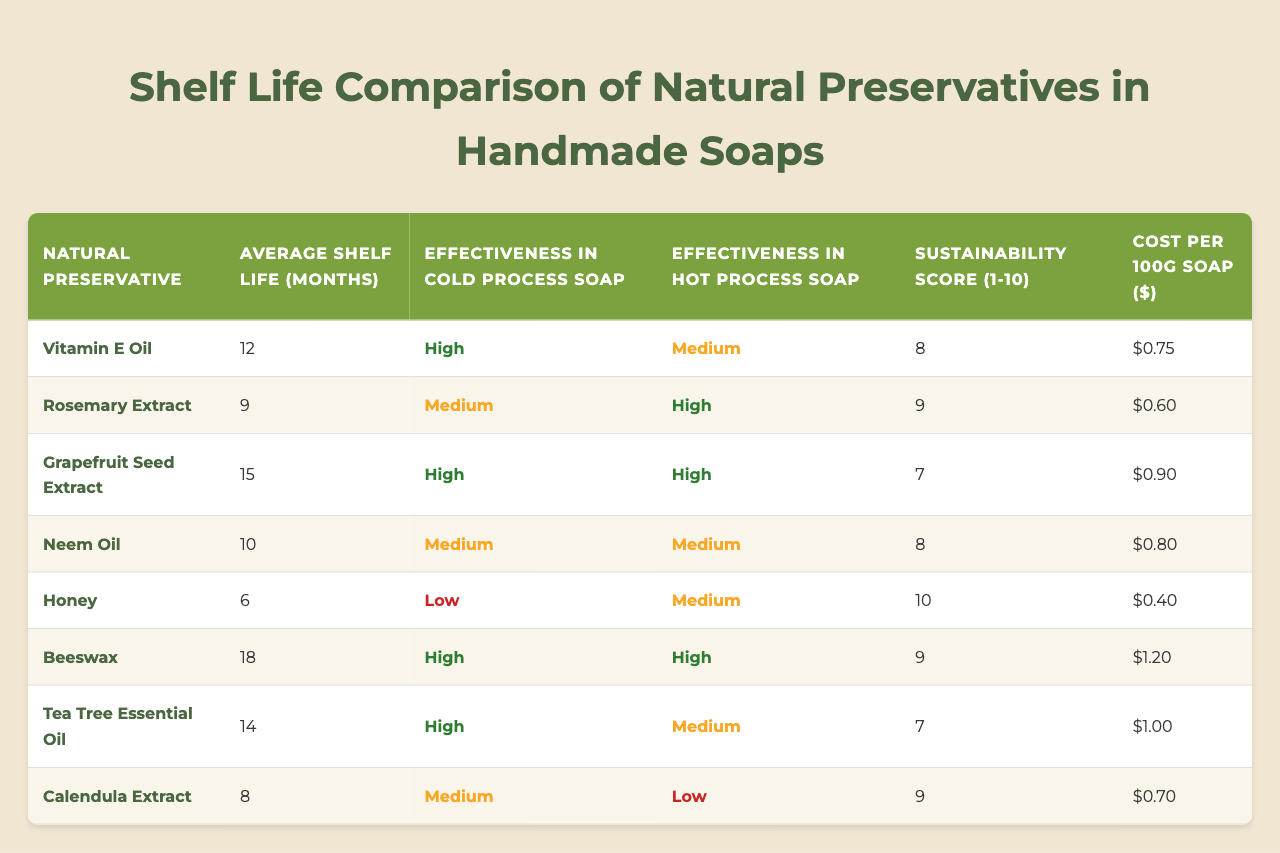What is the average shelf life of the natural preservatives listed? To find the average shelf life, we can sum the shelf lives of all preservatives: (12 + 9 + 15 + 10 + 6 + 18 + 14 + 8) = 92 months. There are 8 preservatives, so the average shelf life is 92/8 = 11.5 months.
Answer: 11.5 months Which natural preservative has the highest sustainability score? Looking at the sustainability scores in the table, the highest score is 10, which is associated with Honey.
Answer: Honey Is Grapefruit Seed Extract more effective in cold process soap than Neem Oil? Grapefruit Seed Extract has "High" effectiveness in cold process soap, while Neem Oil has "Medium." Therefore, Grapefruit Seed Extract is indeed more effective.
Answer: Yes What is the cost per 100g of Beeswax? The cost per 100g of Beeswax is listed directly in the table as $1.20.
Answer: $1.20 Which natural preservative has the longest average shelf life, and what is that shelf life? Looking at the average shelf life values, Grapefruit Seed Extract has the longest shelf life at 15 months.
Answer: Grapefruit Seed Extract, 15 months Are all the natural preservatives effective in hot process soap? The effectiveness in hot process soap for some preservatives is "Low," such as Calendula Extract. This indicates that not all preservatives are effective.
Answer: No If you only consider the preservatives with a sustainability score of 9 or higher, what is the average shelf life? The selected preservatives with a score of 9 or higher are Rosemary Extract (9 months), Beeswax (18 months), Tea Tree Essential Oil (14 months), and Calendula Extract (8 months). Their average shelf life is (9 + 18 + 14 + 8) = 49 months. There are 4 preservatives, so the average is 49/4 = 12.25 months.
Answer: 12.25 months Which preservative is the least sustainable? The sustainability scores indicate that Grapefruit Seed Extract has the lowest sustainability score of 7.
Answer: Grapefruit Seed Extract Is there a preservative that is effective in both cold process and hot process soap? Yes, looking at the table, Grapefruit Seed Extract is effective in both cases, listed as "High" for cold process and "High" for hot process as well.
Answer: Yes What is the difference in average shelf life between Vitamin E Oil and Honey? Vitamin E Oil has an average shelf life of 12 months, and Honey has 6 months. The difference is 12 - 6 = 6 months.
Answer: 6 months 